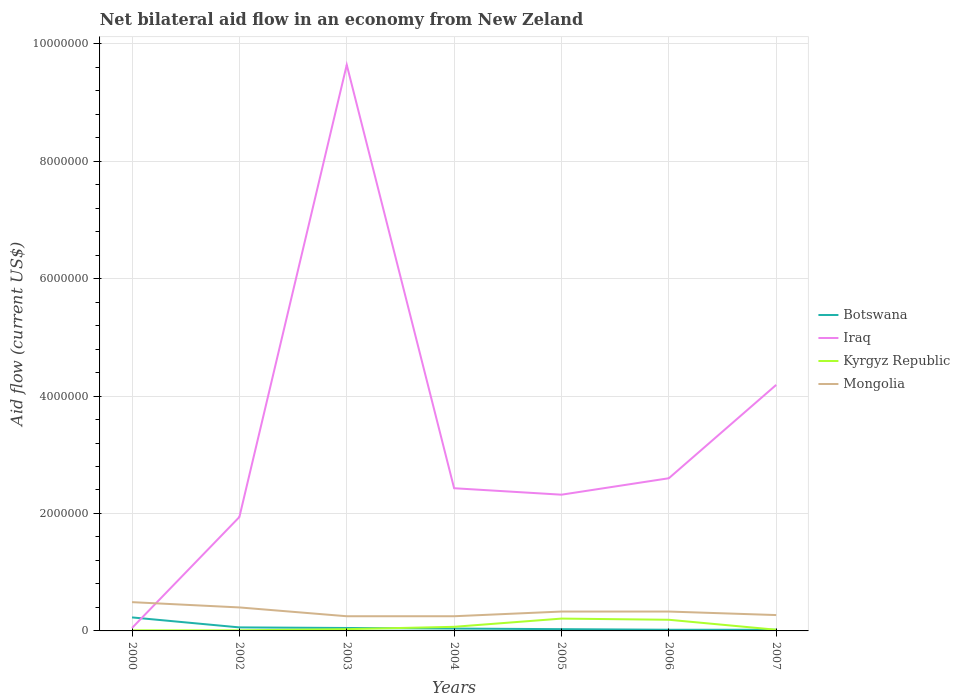How many different coloured lines are there?
Make the answer very short. 4. Does the line corresponding to Iraq intersect with the line corresponding to Kyrgyz Republic?
Give a very brief answer. No. Is the number of lines equal to the number of legend labels?
Your answer should be very brief. Yes. Across all years, what is the maximum net bilateral aid flow in Mongolia?
Give a very brief answer. 2.50e+05. In which year was the net bilateral aid flow in Kyrgyz Republic maximum?
Your answer should be very brief. 2000. What is the total net bilateral aid flow in Iraq in the graph?
Offer a very short reply. -1.59e+06. What is the difference between the highest and the second highest net bilateral aid flow in Kyrgyz Republic?
Give a very brief answer. 2.00e+05. Where does the legend appear in the graph?
Provide a succinct answer. Center right. How many legend labels are there?
Keep it short and to the point. 4. How are the legend labels stacked?
Your answer should be very brief. Vertical. What is the title of the graph?
Provide a short and direct response. Net bilateral aid flow in an economy from New Zeland. What is the Aid flow (current US$) of Iraq in 2002?
Your response must be concise. 1.94e+06. What is the Aid flow (current US$) of Mongolia in 2002?
Provide a succinct answer. 4.00e+05. What is the Aid flow (current US$) in Iraq in 2003?
Offer a terse response. 9.64e+06. What is the Aid flow (current US$) of Mongolia in 2003?
Give a very brief answer. 2.50e+05. What is the Aid flow (current US$) in Botswana in 2004?
Offer a terse response. 4.00e+04. What is the Aid flow (current US$) in Iraq in 2004?
Your answer should be compact. 2.43e+06. What is the Aid flow (current US$) of Kyrgyz Republic in 2004?
Your answer should be compact. 7.00e+04. What is the Aid flow (current US$) in Iraq in 2005?
Your answer should be very brief. 2.32e+06. What is the Aid flow (current US$) in Botswana in 2006?
Your answer should be compact. 2.00e+04. What is the Aid flow (current US$) in Iraq in 2006?
Offer a terse response. 2.60e+06. What is the Aid flow (current US$) of Kyrgyz Republic in 2006?
Make the answer very short. 1.90e+05. What is the Aid flow (current US$) in Mongolia in 2006?
Provide a succinct answer. 3.30e+05. What is the Aid flow (current US$) in Iraq in 2007?
Provide a short and direct response. 4.19e+06. Across all years, what is the maximum Aid flow (current US$) of Botswana?
Ensure brevity in your answer.  2.30e+05. Across all years, what is the maximum Aid flow (current US$) of Iraq?
Your answer should be very brief. 9.64e+06. Across all years, what is the minimum Aid flow (current US$) of Kyrgyz Republic?
Keep it short and to the point. 10000. What is the total Aid flow (current US$) in Iraq in the graph?
Your answer should be compact. 2.32e+07. What is the total Aid flow (current US$) in Kyrgyz Republic in the graph?
Your answer should be compact. 5.40e+05. What is the total Aid flow (current US$) of Mongolia in the graph?
Provide a short and direct response. 2.32e+06. What is the difference between the Aid flow (current US$) of Botswana in 2000 and that in 2002?
Ensure brevity in your answer.  1.70e+05. What is the difference between the Aid flow (current US$) in Iraq in 2000 and that in 2002?
Provide a succinct answer. -1.89e+06. What is the difference between the Aid flow (current US$) in Kyrgyz Republic in 2000 and that in 2002?
Your answer should be compact. 0. What is the difference between the Aid flow (current US$) in Botswana in 2000 and that in 2003?
Provide a succinct answer. 1.80e+05. What is the difference between the Aid flow (current US$) in Iraq in 2000 and that in 2003?
Give a very brief answer. -9.59e+06. What is the difference between the Aid flow (current US$) of Iraq in 2000 and that in 2004?
Your answer should be very brief. -2.38e+06. What is the difference between the Aid flow (current US$) of Mongolia in 2000 and that in 2004?
Make the answer very short. 2.40e+05. What is the difference between the Aid flow (current US$) in Botswana in 2000 and that in 2005?
Keep it short and to the point. 2.00e+05. What is the difference between the Aid flow (current US$) of Iraq in 2000 and that in 2005?
Offer a very short reply. -2.27e+06. What is the difference between the Aid flow (current US$) in Kyrgyz Republic in 2000 and that in 2005?
Your answer should be compact. -2.00e+05. What is the difference between the Aid flow (current US$) of Mongolia in 2000 and that in 2005?
Ensure brevity in your answer.  1.60e+05. What is the difference between the Aid flow (current US$) of Iraq in 2000 and that in 2006?
Your response must be concise. -2.55e+06. What is the difference between the Aid flow (current US$) of Iraq in 2000 and that in 2007?
Ensure brevity in your answer.  -4.14e+06. What is the difference between the Aid flow (current US$) in Mongolia in 2000 and that in 2007?
Ensure brevity in your answer.  2.20e+05. What is the difference between the Aid flow (current US$) in Iraq in 2002 and that in 2003?
Your answer should be compact. -7.70e+06. What is the difference between the Aid flow (current US$) of Botswana in 2002 and that in 2004?
Give a very brief answer. 2.00e+04. What is the difference between the Aid flow (current US$) of Iraq in 2002 and that in 2004?
Ensure brevity in your answer.  -4.90e+05. What is the difference between the Aid flow (current US$) of Kyrgyz Republic in 2002 and that in 2004?
Ensure brevity in your answer.  -6.00e+04. What is the difference between the Aid flow (current US$) of Mongolia in 2002 and that in 2004?
Give a very brief answer. 1.50e+05. What is the difference between the Aid flow (current US$) of Iraq in 2002 and that in 2005?
Your answer should be very brief. -3.80e+05. What is the difference between the Aid flow (current US$) in Kyrgyz Republic in 2002 and that in 2005?
Your answer should be very brief. -2.00e+05. What is the difference between the Aid flow (current US$) of Mongolia in 2002 and that in 2005?
Your answer should be very brief. 7.00e+04. What is the difference between the Aid flow (current US$) in Iraq in 2002 and that in 2006?
Make the answer very short. -6.60e+05. What is the difference between the Aid flow (current US$) in Botswana in 2002 and that in 2007?
Your answer should be very brief. 4.00e+04. What is the difference between the Aid flow (current US$) in Iraq in 2002 and that in 2007?
Offer a very short reply. -2.25e+06. What is the difference between the Aid flow (current US$) of Iraq in 2003 and that in 2004?
Give a very brief answer. 7.21e+06. What is the difference between the Aid flow (current US$) in Mongolia in 2003 and that in 2004?
Provide a succinct answer. 0. What is the difference between the Aid flow (current US$) in Botswana in 2003 and that in 2005?
Offer a terse response. 2.00e+04. What is the difference between the Aid flow (current US$) in Iraq in 2003 and that in 2005?
Offer a terse response. 7.32e+06. What is the difference between the Aid flow (current US$) in Kyrgyz Republic in 2003 and that in 2005?
Keep it short and to the point. -1.80e+05. What is the difference between the Aid flow (current US$) of Iraq in 2003 and that in 2006?
Ensure brevity in your answer.  7.04e+06. What is the difference between the Aid flow (current US$) of Mongolia in 2003 and that in 2006?
Make the answer very short. -8.00e+04. What is the difference between the Aid flow (current US$) of Botswana in 2003 and that in 2007?
Your response must be concise. 3.00e+04. What is the difference between the Aid flow (current US$) of Iraq in 2003 and that in 2007?
Offer a very short reply. 5.45e+06. What is the difference between the Aid flow (current US$) of Botswana in 2004 and that in 2005?
Give a very brief answer. 10000. What is the difference between the Aid flow (current US$) of Kyrgyz Republic in 2004 and that in 2005?
Your answer should be very brief. -1.40e+05. What is the difference between the Aid flow (current US$) of Mongolia in 2004 and that in 2005?
Make the answer very short. -8.00e+04. What is the difference between the Aid flow (current US$) of Botswana in 2004 and that in 2006?
Give a very brief answer. 2.00e+04. What is the difference between the Aid flow (current US$) of Mongolia in 2004 and that in 2006?
Your answer should be compact. -8.00e+04. What is the difference between the Aid flow (current US$) in Iraq in 2004 and that in 2007?
Provide a short and direct response. -1.76e+06. What is the difference between the Aid flow (current US$) of Kyrgyz Republic in 2004 and that in 2007?
Your answer should be compact. 5.00e+04. What is the difference between the Aid flow (current US$) in Botswana in 2005 and that in 2006?
Make the answer very short. 10000. What is the difference between the Aid flow (current US$) in Iraq in 2005 and that in 2006?
Give a very brief answer. -2.80e+05. What is the difference between the Aid flow (current US$) of Kyrgyz Republic in 2005 and that in 2006?
Offer a terse response. 2.00e+04. What is the difference between the Aid flow (current US$) in Botswana in 2005 and that in 2007?
Offer a very short reply. 10000. What is the difference between the Aid flow (current US$) of Iraq in 2005 and that in 2007?
Offer a very short reply. -1.87e+06. What is the difference between the Aid flow (current US$) in Mongolia in 2005 and that in 2007?
Make the answer very short. 6.00e+04. What is the difference between the Aid flow (current US$) of Iraq in 2006 and that in 2007?
Ensure brevity in your answer.  -1.59e+06. What is the difference between the Aid flow (current US$) in Kyrgyz Republic in 2006 and that in 2007?
Offer a terse response. 1.70e+05. What is the difference between the Aid flow (current US$) of Mongolia in 2006 and that in 2007?
Your answer should be compact. 6.00e+04. What is the difference between the Aid flow (current US$) in Botswana in 2000 and the Aid flow (current US$) in Iraq in 2002?
Your answer should be compact. -1.71e+06. What is the difference between the Aid flow (current US$) in Botswana in 2000 and the Aid flow (current US$) in Kyrgyz Republic in 2002?
Offer a very short reply. 2.20e+05. What is the difference between the Aid flow (current US$) in Botswana in 2000 and the Aid flow (current US$) in Mongolia in 2002?
Provide a short and direct response. -1.70e+05. What is the difference between the Aid flow (current US$) of Iraq in 2000 and the Aid flow (current US$) of Mongolia in 2002?
Give a very brief answer. -3.50e+05. What is the difference between the Aid flow (current US$) of Kyrgyz Republic in 2000 and the Aid flow (current US$) of Mongolia in 2002?
Ensure brevity in your answer.  -3.90e+05. What is the difference between the Aid flow (current US$) in Botswana in 2000 and the Aid flow (current US$) in Iraq in 2003?
Give a very brief answer. -9.41e+06. What is the difference between the Aid flow (current US$) of Botswana in 2000 and the Aid flow (current US$) of Kyrgyz Republic in 2003?
Give a very brief answer. 2.00e+05. What is the difference between the Aid flow (current US$) of Botswana in 2000 and the Aid flow (current US$) of Mongolia in 2003?
Keep it short and to the point. -2.00e+04. What is the difference between the Aid flow (current US$) of Iraq in 2000 and the Aid flow (current US$) of Kyrgyz Republic in 2003?
Keep it short and to the point. 2.00e+04. What is the difference between the Aid flow (current US$) in Iraq in 2000 and the Aid flow (current US$) in Mongolia in 2003?
Offer a terse response. -2.00e+05. What is the difference between the Aid flow (current US$) in Kyrgyz Republic in 2000 and the Aid flow (current US$) in Mongolia in 2003?
Keep it short and to the point. -2.40e+05. What is the difference between the Aid flow (current US$) of Botswana in 2000 and the Aid flow (current US$) of Iraq in 2004?
Give a very brief answer. -2.20e+06. What is the difference between the Aid flow (current US$) of Iraq in 2000 and the Aid flow (current US$) of Kyrgyz Republic in 2004?
Provide a short and direct response. -2.00e+04. What is the difference between the Aid flow (current US$) of Iraq in 2000 and the Aid flow (current US$) of Mongolia in 2004?
Your answer should be very brief. -2.00e+05. What is the difference between the Aid flow (current US$) in Botswana in 2000 and the Aid flow (current US$) in Iraq in 2005?
Your answer should be compact. -2.09e+06. What is the difference between the Aid flow (current US$) of Botswana in 2000 and the Aid flow (current US$) of Kyrgyz Republic in 2005?
Provide a short and direct response. 2.00e+04. What is the difference between the Aid flow (current US$) of Iraq in 2000 and the Aid flow (current US$) of Mongolia in 2005?
Your response must be concise. -2.80e+05. What is the difference between the Aid flow (current US$) in Kyrgyz Republic in 2000 and the Aid flow (current US$) in Mongolia in 2005?
Offer a terse response. -3.20e+05. What is the difference between the Aid flow (current US$) of Botswana in 2000 and the Aid flow (current US$) of Iraq in 2006?
Keep it short and to the point. -2.37e+06. What is the difference between the Aid flow (current US$) of Iraq in 2000 and the Aid flow (current US$) of Kyrgyz Republic in 2006?
Make the answer very short. -1.40e+05. What is the difference between the Aid flow (current US$) of Iraq in 2000 and the Aid flow (current US$) of Mongolia in 2006?
Keep it short and to the point. -2.80e+05. What is the difference between the Aid flow (current US$) of Kyrgyz Republic in 2000 and the Aid flow (current US$) of Mongolia in 2006?
Offer a terse response. -3.20e+05. What is the difference between the Aid flow (current US$) of Botswana in 2000 and the Aid flow (current US$) of Iraq in 2007?
Your answer should be very brief. -3.96e+06. What is the difference between the Aid flow (current US$) in Botswana in 2002 and the Aid flow (current US$) in Iraq in 2003?
Make the answer very short. -9.58e+06. What is the difference between the Aid flow (current US$) in Iraq in 2002 and the Aid flow (current US$) in Kyrgyz Republic in 2003?
Ensure brevity in your answer.  1.91e+06. What is the difference between the Aid flow (current US$) in Iraq in 2002 and the Aid flow (current US$) in Mongolia in 2003?
Offer a very short reply. 1.69e+06. What is the difference between the Aid flow (current US$) of Kyrgyz Republic in 2002 and the Aid flow (current US$) of Mongolia in 2003?
Your answer should be very brief. -2.40e+05. What is the difference between the Aid flow (current US$) of Botswana in 2002 and the Aid flow (current US$) of Iraq in 2004?
Your answer should be very brief. -2.37e+06. What is the difference between the Aid flow (current US$) in Iraq in 2002 and the Aid flow (current US$) in Kyrgyz Republic in 2004?
Your answer should be very brief. 1.87e+06. What is the difference between the Aid flow (current US$) in Iraq in 2002 and the Aid flow (current US$) in Mongolia in 2004?
Your answer should be very brief. 1.69e+06. What is the difference between the Aid flow (current US$) of Botswana in 2002 and the Aid flow (current US$) of Iraq in 2005?
Provide a succinct answer. -2.26e+06. What is the difference between the Aid flow (current US$) in Botswana in 2002 and the Aid flow (current US$) in Kyrgyz Republic in 2005?
Ensure brevity in your answer.  -1.50e+05. What is the difference between the Aid flow (current US$) in Botswana in 2002 and the Aid flow (current US$) in Mongolia in 2005?
Keep it short and to the point. -2.70e+05. What is the difference between the Aid flow (current US$) of Iraq in 2002 and the Aid flow (current US$) of Kyrgyz Republic in 2005?
Your answer should be compact. 1.73e+06. What is the difference between the Aid flow (current US$) in Iraq in 2002 and the Aid flow (current US$) in Mongolia in 2005?
Offer a terse response. 1.61e+06. What is the difference between the Aid flow (current US$) of Kyrgyz Republic in 2002 and the Aid flow (current US$) of Mongolia in 2005?
Give a very brief answer. -3.20e+05. What is the difference between the Aid flow (current US$) of Botswana in 2002 and the Aid flow (current US$) of Iraq in 2006?
Your answer should be very brief. -2.54e+06. What is the difference between the Aid flow (current US$) in Botswana in 2002 and the Aid flow (current US$) in Kyrgyz Republic in 2006?
Make the answer very short. -1.30e+05. What is the difference between the Aid flow (current US$) in Iraq in 2002 and the Aid flow (current US$) in Kyrgyz Republic in 2006?
Ensure brevity in your answer.  1.75e+06. What is the difference between the Aid flow (current US$) in Iraq in 2002 and the Aid flow (current US$) in Mongolia in 2006?
Make the answer very short. 1.61e+06. What is the difference between the Aid flow (current US$) in Kyrgyz Republic in 2002 and the Aid flow (current US$) in Mongolia in 2006?
Offer a terse response. -3.20e+05. What is the difference between the Aid flow (current US$) in Botswana in 2002 and the Aid flow (current US$) in Iraq in 2007?
Your answer should be very brief. -4.13e+06. What is the difference between the Aid flow (current US$) of Botswana in 2002 and the Aid flow (current US$) of Kyrgyz Republic in 2007?
Provide a short and direct response. 4.00e+04. What is the difference between the Aid flow (current US$) in Botswana in 2002 and the Aid flow (current US$) in Mongolia in 2007?
Offer a terse response. -2.10e+05. What is the difference between the Aid flow (current US$) of Iraq in 2002 and the Aid flow (current US$) of Kyrgyz Republic in 2007?
Provide a short and direct response. 1.92e+06. What is the difference between the Aid flow (current US$) of Iraq in 2002 and the Aid flow (current US$) of Mongolia in 2007?
Provide a succinct answer. 1.67e+06. What is the difference between the Aid flow (current US$) in Kyrgyz Republic in 2002 and the Aid flow (current US$) in Mongolia in 2007?
Your response must be concise. -2.60e+05. What is the difference between the Aid flow (current US$) in Botswana in 2003 and the Aid flow (current US$) in Iraq in 2004?
Provide a short and direct response. -2.38e+06. What is the difference between the Aid flow (current US$) in Botswana in 2003 and the Aid flow (current US$) in Kyrgyz Republic in 2004?
Provide a short and direct response. -2.00e+04. What is the difference between the Aid flow (current US$) in Iraq in 2003 and the Aid flow (current US$) in Kyrgyz Republic in 2004?
Offer a very short reply. 9.57e+06. What is the difference between the Aid flow (current US$) in Iraq in 2003 and the Aid flow (current US$) in Mongolia in 2004?
Offer a very short reply. 9.39e+06. What is the difference between the Aid flow (current US$) in Kyrgyz Republic in 2003 and the Aid flow (current US$) in Mongolia in 2004?
Your answer should be very brief. -2.20e+05. What is the difference between the Aid flow (current US$) of Botswana in 2003 and the Aid flow (current US$) of Iraq in 2005?
Make the answer very short. -2.27e+06. What is the difference between the Aid flow (current US$) of Botswana in 2003 and the Aid flow (current US$) of Mongolia in 2005?
Make the answer very short. -2.80e+05. What is the difference between the Aid flow (current US$) in Iraq in 2003 and the Aid flow (current US$) in Kyrgyz Republic in 2005?
Keep it short and to the point. 9.43e+06. What is the difference between the Aid flow (current US$) of Iraq in 2003 and the Aid flow (current US$) of Mongolia in 2005?
Give a very brief answer. 9.31e+06. What is the difference between the Aid flow (current US$) in Botswana in 2003 and the Aid flow (current US$) in Iraq in 2006?
Your answer should be very brief. -2.55e+06. What is the difference between the Aid flow (current US$) of Botswana in 2003 and the Aid flow (current US$) of Kyrgyz Republic in 2006?
Keep it short and to the point. -1.40e+05. What is the difference between the Aid flow (current US$) in Botswana in 2003 and the Aid flow (current US$) in Mongolia in 2006?
Keep it short and to the point. -2.80e+05. What is the difference between the Aid flow (current US$) of Iraq in 2003 and the Aid flow (current US$) of Kyrgyz Republic in 2006?
Your response must be concise. 9.45e+06. What is the difference between the Aid flow (current US$) of Iraq in 2003 and the Aid flow (current US$) of Mongolia in 2006?
Keep it short and to the point. 9.31e+06. What is the difference between the Aid flow (current US$) in Kyrgyz Republic in 2003 and the Aid flow (current US$) in Mongolia in 2006?
Your response must be concise. -3.00e+05. What is the difference between the Aid flow (current US$) of Botswana in 2003 and the Aid flow (current US$) of Iraq in 2007?
Your answer should be compact. -4.14e+06. What is the difference between the Aid flow (current US$) of Botswana in 2003 and the Aid flow (current US$) of Mongolia in 2007?
Provide a succinct answer. -2.20e+05. What is the difference between the Aid flow (current US$) in Iraq in 2003 and the Aid flow (current US$) in Kyrgyz Republic in 2007?
Provide a short and direct response. 9.62e+06. What is the difference between the Aid flow (current US$) in Iraq in 2003 and the Aid flow (current US$) in Mongolia in 2007?
Ensure brevity in your answer.  9.37e+06. What is the difference between the Aid flow (current US$) in Kyrgyz Republic in 2003 and the Aid flow (current US$) in Mongolia in 2007?
Keep it short and to the point. -2.40e+05. What is the difference between the Aid flow (current US$) of Botswana in 2004 and the Aid flow (current US$) of Iraq in 2005?
Provide a short and direct response. -2.28e+06. What is the difference between the Aid flow (current US$) of Botswana in 2004 and the Aid flow (current US$) of Kyrgyz Republic in 2005?
Offer a terse response. -1.70e+05. What is the difference between the Aid flow (current US$) of Iraq in 2004 and the Aid flow (current US$) of Kyrgyz Republic in 2005?
Keep it short and to the point. 2.22e+06. What is the difference between the Aid flow (current US$) in Iraq in 2004 and the Aid flow (current US$) in Mongolia in 2005?
Your answer should be compact. 2.10e+06. What is the difference between the Aid flow (current US$) in Kyrgyz Republic in 2004 and the Aid flow (current US$) in Mongolia in 2005?
Offer a terse response. -2.60e+05. What is the difference between the Aid flow (current US$) in Botswana in 2004 and the Aid flow (current US$) in Iraq in 2006?
Keep it short and to the point. -2.56e+06. What is the difference between the Aid flow (current US$) of Botswana in 2004 and the Aid flow (current US$) of Kyrgyz Republic in 2006?
Offer a very short reply. -1.50e+05. What is the difference between the Aid flow (current US$) of Iraq in 2004 and the Aid flow (current US$) of Kyrgyz Republic in 2006?
Offer a very short reply. 2.24e+06. What is the difference between the Aid flow (current US$) in Iraq in 2004 and the Aid flow (current US$) in Mongolia in 2006?
Offer a very short reply. 2.10e+06. What is the difference between the Aid flow (current US$) in Botswana in 2004 and the Aid flow (current US$) in Iraq in 2007?
Keep it short and to the point. -4.15e+06. What is the difference between the Aid flow (current US$) in Botswana in 2004 and the Aid flow (current US$) in Kyrgyz Republic in 2007?
Your answer should be compact. 2.00e+04. What is the difference between the Aid flow (current US$) in Iraq in 2004 and the Aid flow (current US$) in Kyrgyz Republic in 2007?
Your response must be concise. 2.41e+06. What is the difference between the Aid flow (current US$) of Iraq in 2004 and the Aid flow (current US$) of Mongolia in 2007?
Offer a very short reply. 2.16e+06. What is the difference between the Aid flow (current US$) in Kyrgyz Republic in 2004 and the Aid flow (current US$) in Mongolia in 2007?
Your answer should be compact. -2.00e+05. What is the difference between the Aid flow (current US$) of Botswana in 2005 and the Aid flow (current US$) of Iraq in 2006?
Ensure brevity in your answer.  -2.57e+06. What is the difference between the Aid flow (current US$) of Botswana in 2005 and the Aid flow (current US$) of Mongolia in 2006?
Ensure brevity in your answer.  -3.00e+05. What is the difference between the Aid flow (current US$) of Iraq in 2005 and the Aid flow (current US$) of Kyrgyz Republic in 2006?
Offer a terse response. 2.13e+06. What is the difference between the Aid flow (current US$) in Iraq in 2005 and the Aid flow (current US$) in Mongolia in 2006?
Your answer should be very brief. 1.99e+06. What is the difference between the Aid flow (current US$) in Kyrgyz Republic in 2005 and the Aid flow (current US$) in Mongolia in 2006?
Provide a succinct answer. -1.20e+05. What is the difference between the Aid flow (current US$) in Botswana in 2005 and the Aid flow (current US$) in Iraq in 2007?
Provide a succinct answer. -4.16e+06. What is the difference between the Aid flow (current US$) of Iraq in 2005 and the Aid flow (current US$) of Kyrgyz Republic in 2007?
Your answer should be very brief. 2.30e+06. What is the difference between the Aid flow (current US$) of Iraq in 2005 and the Aid flow (current US$) of Mongolia in 2007?
Your response must be concise. 2.05e+06. What is the difference between the Aid flow (current US$) in Kyrgyz Republic in 2005 and the Aid flow (current US$) in Mongolia in 2007?
Provide a succinct answer. -6.00e+04. What is the difference between the Aid flow (current US$) in Botswana in 2006 and the Aid flow (current US$) in Iraq in 2007?
Ensure brevity in your answer.  -4.17e+06. What is the difference between the Aid flow (current US$) of Botswana in 2006 and the Aid flow (current US$) of Kyrgyz Republic in 2007?
Provide a short and direct response. 0. What is the difference between the Aid flow (current US$) in Iraq in 2006 and the Aid flow (current US$) in Kyrgyz Republic in 2007?
Your response must be concise. 2.58e+06. What is the difference between the Aid flow (current US$) in Iraq in 2006 and the Aid flow (current US$) in Mongolia in 2007?
Make the answer very short. 2.33e+06. What is the difference between the Aid flow (current US$) in Kyrgyz Republic in 2006 and the Aid flow (current US$) in Mongolia in 2007?
Keep it short and to the point. -8.00e+04. What is the average Aid flow (current US$) of Botswana per year?
Your answer should be compact. 6.43e+04. What is the average Aid flow (current US$) of Iraq per year?
Your response must be concise. 3.31e+06. What is the average Aid flow (current US$) in Kyrgyz Republic per year?
Your answer should be compact. 7.71e+04. What is the average Aid flow (current US$) of Mongolia per year?
Provide a short and direct response. 3.31e+05. In the year 2000, what is the difference between the Aid flow (current US$) in Botswana and Aid flow (current US$) in Kyrgyz Republic?
Your response must be concise. 2.20e+05. In the year 2000, what is the difference between the Aid flow (current US$) of Iraq and Aid flow (current US$) of Kyrgyz Republic?
Your answer should be very brief. 4.00e+04. In the year 2000, what is the difference between the Aid flow (current US$) in Iraq and Aid flow (current US$) in Mongolia?
Keep it short and to the point. -4.40e+05. In the year 2000, what is the difference between the Aid flow (current US$) of Kyrgyz Republic and Aid flow (current US$) of Mongolia?
Your answer should be very brief. -4.80e+05. In the year 2002, what is the difference between the Aid flow (current US$) of Botswana and Aid flow (current US$) of Iraq?
Provide a short and direct response. -1.88e+06. In the year 2002, what is the difference between the Aid flow (current US$) of Botswana and Aid flow (current US$) of Mongolia?
Give a very brief answer. -3.40e+05. In the year 2002, what is the difference between the Aid flow (current US$) of Iraq and Aid flow (current US$) of Kyrgyz Republic?
Your answer should be compact. 1.93e+06. In the year 2002, what is the difference between the Aid flow (current US$) of Iraq and Aid flow (current US$) of Mongolia?
Your answer should be compact. 1.54e+06. In the year 2002, what is the difference between the Aid flow (current US$) of Kyrgyz Republic and Aid flow (current US$) of Mongolia?
Keep it short and to the point. -3.90e+05. In the year 2003, what is the difference between the Aid flow (current US$) of Botswana and Aid flow (current US$) of Iraq?
Provide a succinct answer. -9.59e+06. In the year 2003, what is the difference between the Aid flow (current US$) of Iraq and Aid flow (current US$) of Kyrgyz Republic?
Make the answer very short. 9.61e+06. In the year 2003, what is the difference between the Aid flow (current US$) in Iraq and Aid flow (current US$) in Mongolia?
Provide a short and direct response. 9.39e+06. In the year 2003, what is the difference between the Aid flow (current US$) in Kyrgyz Republic and Aid flow (current US$) in Mongolia?
Your answer should be very brief. -2.20e+05. In the year 2004, what is the difference between the Aid flow (current US$) in Botswana and Aid flow (current US$) in Iraq?
Offer a terse response. -2.39e+06. In the year 2004, what is the difference between the Aid flow (current US$) in Iraq and Aid flow (current US$) in Kyrgyz Republic?
Ensure brevity in your answer.  2.36e+06. In the year 2004, what is the difference between the Aid flow (current US$) of Iraq and Aid flow (current US$) of Mongolia?
Ensure brevity in your answer.  2.18e+06. In the year 2005, what is the difference between the Aid flow (current US$) of Botswana and Aid flow (current US$) of Iraq?
Provide a short and direct response. -2.29e+06. In the year 2005, what is the difference between the Aid flow (current US$) in Botswana and Aid flow (current US$) in Kyrgyz Republic?
Your answer should be very brief. -1.80e+05. In the year 2005, what is the difference between the Aid flow (current US$) in Iraq and Aid flow (current US$) in Kyrgyz Republic?
Offer a terse response. 2.11e+06. In the year 2005, what is the difference between the Aid flow (current US$) of Iraq and Aid flow (current US$) of Mongolia?
Offer a very short reply. 1.99e+06. In the year 2006, what is the difference between the Aid flow (current US$) of Botswana and Aid flow (current US$) of Iraq?
Keep it short and to the point. -2.58e+06. In the year 2006, what is the difference between the Aid flow (current US$) of Botswana and Aid flow (current US$) of Kyrgyz Republic?
Provide a succinct answer. -1.70e+05. In the year 2006, what is the difference between the Aid flow (current US$) in Botswana and Aid flow (current US$) in Mongolia?
Your answer should be compact. -3.10e+05. In the year 2006, what is the difference between the Aid flow (current US$) of Iraq and Aid flow (current US$) of Kyrgyz Republic?
Offer a very short reply. 2.41e+06. In the year 2006, what is the difference between the Aid flow (current US$) in Iraq and Aid flow (current US$) in Mongolia?
Your answer should be very brief. 2.27e+06. In the year 2006, what is the difference between the Aid flow (current US$) in Kyrgyz Republic and Aid flow (current US$) in Mongolia?
Give a very brief answer. -1.40e+05. In the year 2007, what is the difference between the Aid flow (current US$) of Botswana and Aid flow (current US$) of Iraq?
Keep it short and to the point. -4.17e+06. In the year 2007, what is the difference between the Aid flow (current US$) in Botswana and Aid flow (current US$) in Kyrgyz Republic?
Keep it short and to the point. 0. In the year 2007, what is the difference between the Aid flow (current US$) of Botswana and Aid flow (current US$) of Mongolia?
Keep it short and to the point. -2.50e+05. In the year 2007, what is the difference between the Aid flow (current US$) of Iraq and Aid flow (current US$) of Kyrgyz Republic?
Provide a short and direct response. 4.17e+06. In the year 2007, what is the difference between the Aid flow (current US$) of Iraq and Aid flow (current US$) of Mongolia?
Your answer should be compact. 3.92e+06. In the year 2007, what is the difference between the Aid flow (current US$) of Kyrgyz Republic and Aid flow (current US$) of Mongolia?
Make the answer very short. -2.50e+05. What is the ratio of the Aid flow (current US$) in Botswana in 2000 to that in 2002?
Provide a short and direct response. 3.83. What is the ratio of the Aid flow (current US$) of Iraq in 2000 to that in 2002?
Make the answer very short. 0.03. What is the ratio of the Aid flow (current US$) in Mongolia in 2000 to that in 2002?
Provide a succinct answer. 1.23. What is the ratio of the Aid flow (current US$) of Iraq in 2000 to that in 2003?
Provide a succinct answer. 0.01. What is the ratio of the Aid flow (current US$) of Kyrgyz Republic in 2000 to that in 2003?
Give a very brief answer. 0.33. What is the ratio of the Aid flow (current US$) in Mongolia in 2000 to that in 2003?
Provide a succinct answer. 1.96. What is the ratio of the Aid flow (current US$) of Botswana in 2000 to that in 2004?
Your answer should be compact. 5.75. What is the ratio of the Aid flow (current US$) of Iraq in 2000 to that in 2004?
Your response must be concise. 0.02. What is the ratio of the Aid flow (current US$) in Kyrgyz Republic in 2000 to that in 2004?
Make the answer very short. 0.14. What is the ratio of the Aid flow (current US$) in Mongolia in 2000 to that in 2004?
Give a very brief answer. 1.96. What is the ratio of the Aid flow (current US$) in Botswana in 2000 to that in 2005?
Provide a short and direct response. 7.67. What is the ratio of the Aid flow (current US$) of Iraq in 2000 to that in 2005?
Offer a terse response. 0.02. What is the ratio of the Aid flow (current US$) in Kyrgyz Republic in 2000 to that in 2005?
Give a very brief answer. 0.05. What is the ratio of the Aid flow (current US$) in Mongolia in 2000 to that in 2005?
Offer a terse response. 1.48. What is the ratio of the Aid flow (current US$) in Iraq in 2000 to that in 2006?
Your answer should be very brief. 0.02. What is the ratio of the Aid flow (current US$) in Kyrgyz Republic in 2000 to that in 2006?
Offer a terse response. 0.05. What is the ratio of the Aid flow (current US$) of Mongolia in 2000 to that in 2006?
Your answer should be compact. 1.48. What is the ratio of the Aid flow (current US$) of Iraq in 2000 to that in 2007?
Offer a terse response. 0.01. What is the ratio of the Aid flow (current US$) of Kyrgyz Republic in 2000 to that in 2007?
Ensure brevity in your answer.  0.5. What is the ratio of the Aid flow (current US$) in Mongolia in 2000 to that in 2007?
Your response must be concise. 1.81. What is the ratio of the Aid flow (current US$) in Botswana in 2002 to that in 2003?
Your response must be concise. 1.2. What is the ratio of the Aid flow (current US$) of Iraq in 2002 to that in 2003?
Offer a terse response. 0.2. What is the ratio of the Aid flow (current US$) in Kyrgyz Republic in 2002 to that in 2003?
Offer a very short reply. 0.33. What is the ratio of the Aid flow (current US$) of Mongolia in 2002 to that in 2003?
Ensure brevity in your answer.  1.6. What is the ratio of the Aid flow (current US$) of Iraq in 2002 to that in 2004?
Offer a terse response. 0.8. What is the ratio of the Aid flow (current US$) in Kyrgyz Republic in 2002 to that in 2004?
Your response must be concise. 0.14. What is the ratio of the Aid flow (current US$) in Mongolia in 2002 to that in 2004?
Provide a succinct answer. 1.6. What is the ratio of the Aid flow (current US$) of Iraq in 2002 to that in 2005?
Give a very brief answer. 0.84. What is the ratio of the Aid flow (current US$) in Kyrgyz Republic in 2002 to that in 2005?
Your response must be concise. 0.05. What is the ratio of the Aid flow (current US$) of Mongolia in 2002 to that in 2005?
Your answer should be very brief. 1.21. What is the ratio of the Aid flow (current US$) of Botswana in 2002 to that in 2006?
Ensure brevity in your answer.  3. What is the ratio of the Aid flow (current US$) of Iraq in 2002 to that in 2006?
Provide a succinct answer. 0.75. What is the ratio of the Aid flow (current US$) in Kyrgyz Republic in 2002 to that in 2006?
Offer a very short reply. 0.05. What is the ratio of the Aid flow (current US$) in Mongolia in 2002 to that in 2006?
Keep it short and to the point. 1.21. What is the ratio of the Aid flow (current US$) of Botswana in 2002 to that in 2007?
Provide a short and direct response. 3. What is the ratio of the Aid flow (current US$) in Iraq in 2002 to that in 2007?
Offer a very short reply. 0.46. What is the ratio of the Aid flow (current US$) in Mongolia in 2002 to that in 2007?
Your answer should be very brief. 1.48. What is the ratio of the Aid flow (current US$) of Botswana in 2003 to that in 2004?
Offer a terse response. 1.25. What is the ratio of the Aid flow (current US$) in Iraq in 2003 to that in 2004?
Give a very brief answer. 3.97. What is the ratio of the Aid flow (current US$) of Kyrgyz Republic in 2003 to that in 2004?
Ensure brevity in your answer.  0.43. What is the ratio of the Aid flow (current US$) in Mongolia in 2003 to that in 2004?
Ensure brevity in your answer.  1. What is the ratio of the Aid flow (current US$) of Iraq in 2003 to that in 2005?
Your response must be concise. 4.16. What is the ratio of the Aid flow (current US$) of Kyrgyz Republic in 2003 to that in 2005?
Give a very brief answer. 0.14. What is the ratio of the Aid flow (current US$) in Mongolia in 2003 to that in 2005?
Give a very brief answer. 0.76. What is the ratio of the Aid flow (current US$) of Botswana in 2003 to that in 2006?
Provide a succinct answer. 2.5. What is the ratio of the Aid flow (current US$) of Iraq in 2003 to that in 2006?
Provide a succinct answer. 3.71. What is the ratio of the Aid flow (current US$) of Kyrgyz Republic in 2003 to that in 2006?
Offer a very short reply. 0.16. What is the ratio of the Aid flow (current US$) in Mongolia in 2003 to that in 2006?
Give a very brief answer. 0.76. What is the ratio of the Aid flow (current US$) in Iraq in 2003 to that in 2007?
Ensure brevity in your answer.  2.3. What is the ratio of the Aid flow (current US$) of Mongolia in 2003 to that in 2007?
Give a very brief answer. 0.93. What is the ratio of the Aid flow (current US$) in Botswana in 2004 to that in 2005?
Make the answer very short. 1.33. What is the ratio of the Aid flow (current US$) of Iraq in 2004 to that in 2005?
Ensure brevity in your answer.  1.05. What is the ratio of the Aid flow (current US$) of Mongolia in 2004 to that in 2005?
Give a very brief answer. 0.76. What is the ratio of the Aid flow (current US$) in Botswana in 2004 to that in 2006?
Your response must be concise. 2. What is the ratio of the Aid flow (current US$) of Iraq in 2004 to that in 2006?
Your answer should be very brief. 0.93. What is the ratio of the Aid flow (current US$) in Kyrgyz Republic in 2004 to that in 2006?
Your response must be concise. 0.37. What is the ratio of the Aid flow (current US$) in Mongolia in 2004 to that in 2006?
Your answer should be very brief. 0.76. What is the ratio of the Aid flow (current US$) of Botswana in 2004 to that in 2007?
Offer a terse response. 2. What is the ratio of the Aid flow (current US$) of Iraq in 2004 to that in 2007?
Your answer should be compact. 0.58. What is the ratio of the Aid flow (current US$) in Kyrgyz Republic in 2004 to that in 2007?
Keep it short and to the point. 3.5. What is the ratio of the Aid flow (current US$) in Mongolia in 2004 to that in 2007?
Provide a succinct answer. 0.93. What is the ratio of the Aid flow (current US$) in Botswana in 2005 to that in 2006?
Provide a short and direct response. 1.5. What is the ratio of the Aid flow (current US$) of Iraq in 2005 to that in 2006?
Provide a succinct answer. 0.89. What is the ratio of the Aid flow (current US$) in Kyrgyz Republic in 2005 to that in 2006?
Offer a terse response. 1.11. What is the ratio of the Aid flow (current US$) of Mongolia in 2005 to that in 2006?
Provide a succinct answer. 1. What is the ratio of the Aid flow (current US$) of Botswana in 2005 to that in 2007?
Your response must be concise. 1.5. What is the ratio of the Aid flow (current US$) of Iraq in 2005 to that in 2007?
Provide a succinct answer. 0.55. What is the ratio of the Aid flow (current US$) in Kyrgyz Republic in 2005 to that in 2007?
Ensure brevity in your answer.  10.5. What is the ratio of the Aid flow (current US$) in Mongolia in 2005 to that in 2007?
Keep it short and to the point. 1.22. What is the ratio of the Aid flow (current US$) of Botswana in 2006 to that in 2007?
Provide a succinct answer. 1. What is the ratio of the Aid flow (current US$) in Iraq in 2006 to that in 2007?
Provide a succinct answer. 0.62. What is the ratio of the Aid flow (current US$) in Mongolia in 2006 to that in 2007?
Your response must be concise. 1.22. What is the difference between the highest and the second highest Aid flow (current US$) of Botswana?
Provide a succinct answer. 1.70e+05. What is the difference between the highest and the second highest Aid flow (current US$) of Iraq?
Ensure brevity in your answer.  5.45e+06. What is the difference between the highest and the second highest Aid flow (current US$) in Mongolia?
Ensure brevity in your answer.  9.00e+04. What is the difference between the highest and the lowest Aid flow (current US$) in Iraq?
Give a very brief answer. 9.59e+06. What is the difference between the highest and the lowest Aid flow (current US$) of Kyrgyz Republic?
Your response must be concise. 2.00e+05. What is the difference between the highest and the lowest Aid flow (current US$) of Mongolia?
Offer a very short reply. 2.40e+05. 